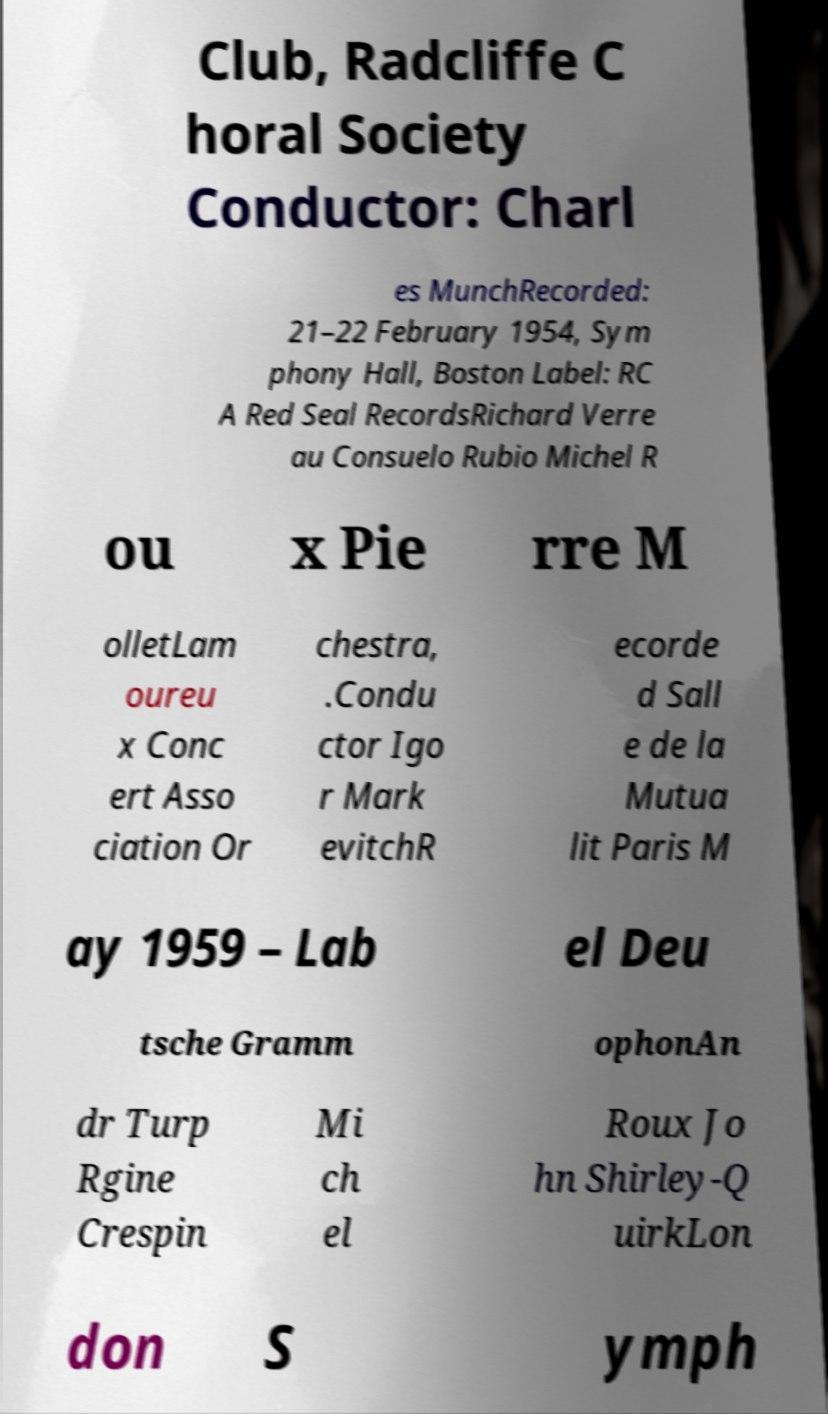Please identify and transcribe the text found in this image. Club, Radcliffe C horal Society Conductor: Charl es MunchRecorded: 21–22 February 1954, Sym phony Hall, Boston Label: RC A Red Seal RecordsRichard Verre au Consuelo Rubio Michel R ou x Pie rre M olletLam oureu x Conc ert Asso ciation Or chestra, .Condu ctor Igo r Mark evitchR ecorde d Sall e de la Mutua lit Paris M ay 1959 – Lab el Deu tsche Gramm ophonAn dr Turp Rgine Crespin Mi ch el Roux Jo hn Shirley-Q uirkLon don S ymph 